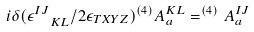<formula> <loc_0><loc_0><loc_500><loc_500>i \delta ( \epsilon ^ { I J } _ { \ \ K L } / 2 \epsilon _ { T X Y Z } ) ^ { ( 4 ) } A ^ { K L } _ { a } = ^ { ( 4 ) } A ^ { I J } _ { a }</formula> 